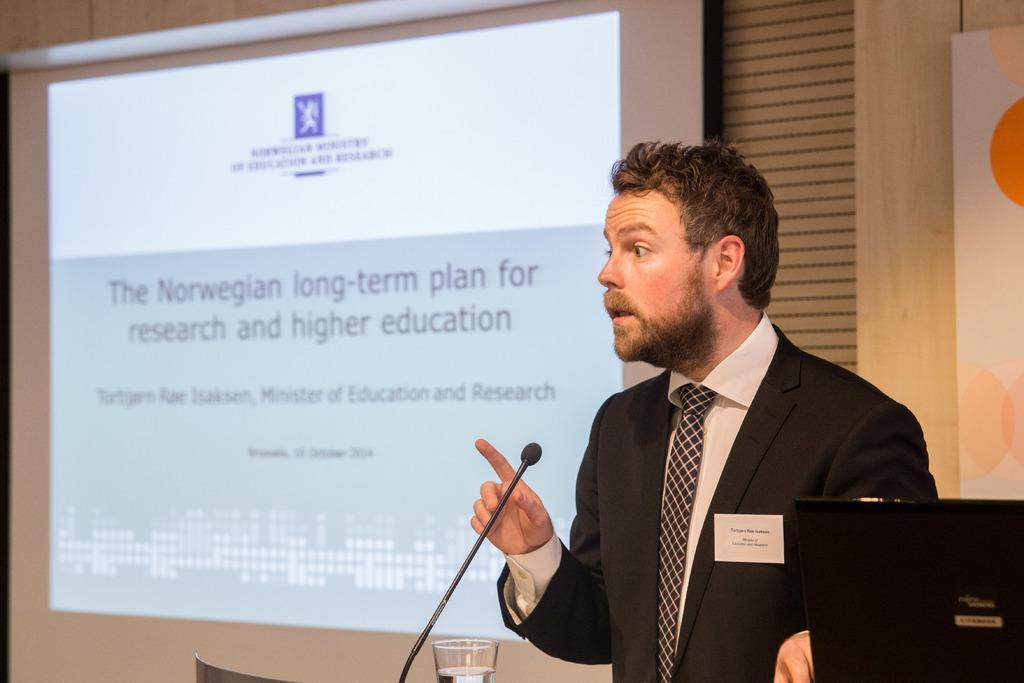Could you give a brief overview of what you see in this image? In this image I can see a person wearing black color dress is stunning. I can see a microphone, a glass and a black colored object in front of him. In the background I can see a projection screen and the wall. 